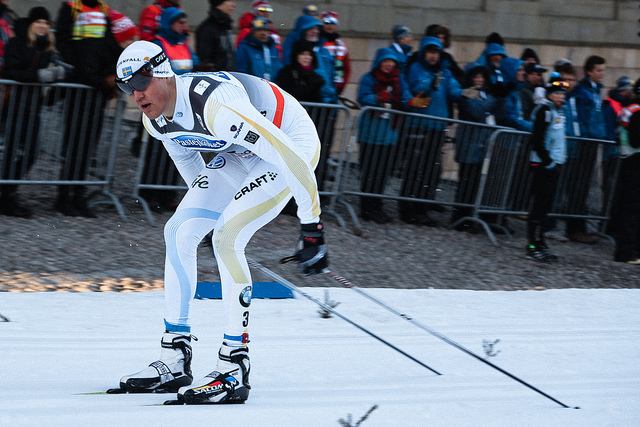Extract all visible text content from this image. CRAFT 3 